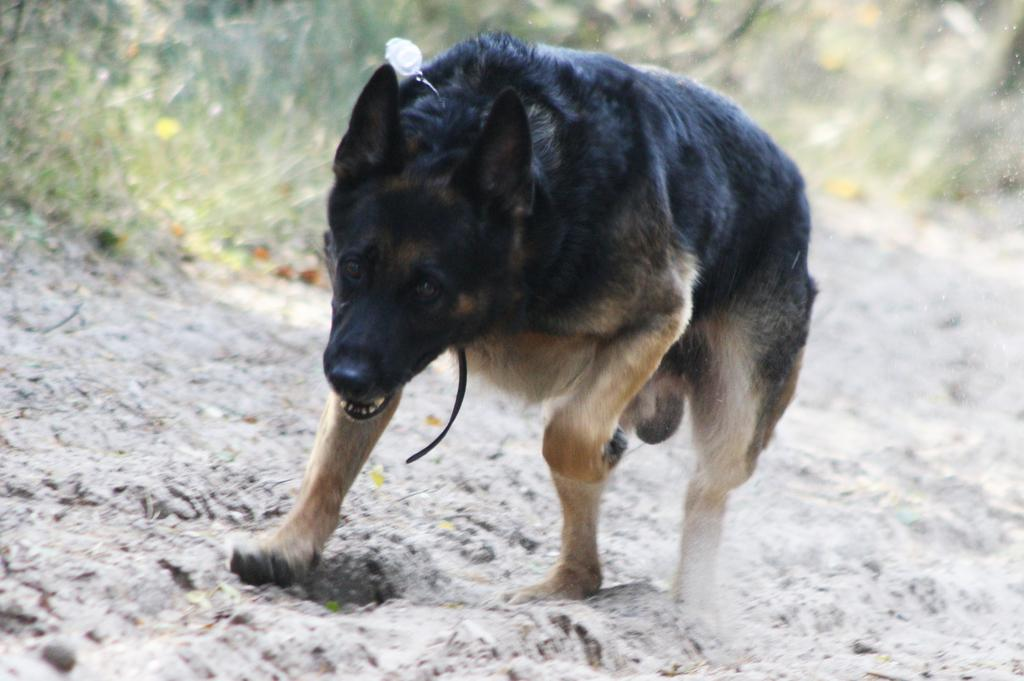What type of animal is in the image? There is a dog in the image. Can you describe the color of the dog? The dog is black and pale brown in color. What type of environment is visible in the image? There is grass visible in the image. How would you describe the quality of the image? The image is slightly blurred. What type of house is visible in the image? There is no house present in the image; it only features a dog and grass. 